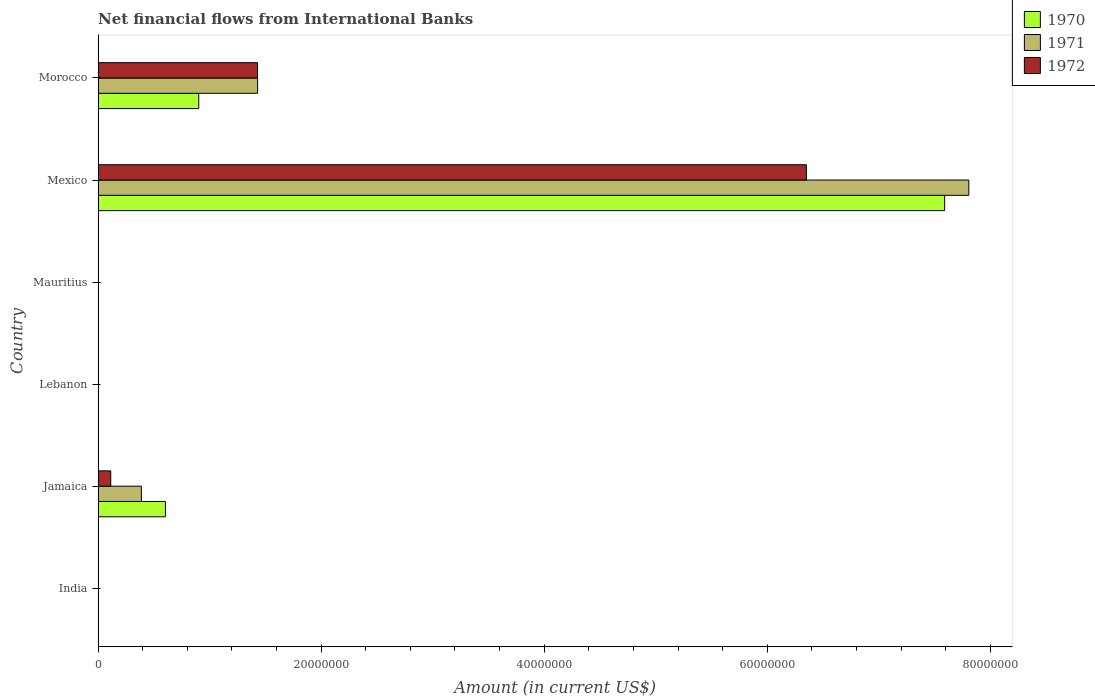How many bars are there on the 6th tick from the top?
Keep it short and to the point. 0. What is the label of the 1st group of bars from the top?
Give a very brief answer. Morocco. In how many cases, is the number of bars for a given country not equal to the number of legend labels?
Give a very brief answer. 3. What is the net financial aid flows in 1971 in Morocco?
Offer a very short reply. 1.43e+07. Across all countries, what is the maximum net financial aid flows in 1971?
Provide a short and direct response. 7.81e+07. In which country was the net financial aid flows in 1972 maximum?
Your answer should be compact. Mexico. What is the total net financial aid flows in 1971 in the graph?
Give a very brief answer. 9.63e+07. What is the difference between the net financial aid flows in 1972 in Morocco and the net financial aid flows in 1971 in Jamaica?
Ensure brevity in your answer.  1.04e+07. What is the average net financial aid flows in 1971 per country?
Give a very brief answer. 1.60e+07. What is the difference between the net financial aid flows in 1970 and net financial aid flows in 1971 in Mexico?
Your answer should be compact. -2.17e+06. What is the ratio of the net financial aid flows in 1971 in Jamaica to that in Morocco?
Your response must be concise. 0.27. What is the difference between the highest and the second highest net financial aid flows in 1970?
Give a very brief answer. 6.69e+07. What is the difference between the highest and the lowest net financial aid flows in 1971?
Make the answer very short. 7.81e+07. In how many countries, is the net financial aid flows in 1972 greater than the average net financial aid flows in 1972 taken over all countries?
Offer a very short reply. 2. Is it the case that in every country, the sum of the net financial aid flows in 1972 and net financial aid flows in 1971 is greater than the net financial aid flows in 1970?
Ensure brevity in your answer.  No. How many bars are there?
Your answer should be very brief. 9. How many countries are there in the graph?
Give a very brief answer. 6. Does the graph contain grids?
Give a very brief answer. No. How many legend labels are there?
Make the answer very short. 3. How are the legend labels stacked?
Make the answer very short. Vertical. What is the title of the graph?
Give a very brief answer. Net financial flows from International Banks. What is the label or title of the X-axis?
Offer a terse response. Amount (in current US$). What is the label or title of the Y-axis?
Your answer should be very brief. Country. What is the Amount (in current US$) of 1971 in India?
Your answer should be very brief. 0. What is the Amount (in current US$) of 1972 in India?
Keep it short and to the point. 0. What is the Amount (in current US$) of 1970 in Jamaica?
Keep it short and to the point. 6.04e+06. What is the Amount (in current US$) of 1971 in Jamaica?
Offer a very short reply. 3.88e+06. What is the Amount (in current US$) of 1972 in Jamaica?
Provide a succinct answer. 1.14e+06. What is the Amount (in current US$) in 1970 in Lebanon?
Make the answer very short. 0. What is the Amount (in current US$) of 1971 in Lebanon?
Give a very brief answer. 0. What is the Amount (in current US$) in 1971 in Mauritius?
Offer a very short reply. 0. What is the Amount (in current US$) in 1970 in Mexico?
Provide a short and direct response. 7.59e+07. What is the Amount (in current US$) of 1971 in Mexico?
Offer a very short reply. 7.81e+07. What is the Amount (in current US$) of 1972 in Mexico?
Your response must be concise. 6.35e+07. What is the Amount (in current US$) of 1970 in Morocco?
Provide a short and direct response. 9.03e+06. What is the Amount (in current US$) in 1971 in Morocco?
Your answer should be very brief. 1.43e+07. What is the Amount (in current US$) in 1972 in Morocco?
Your answer should be compact. 1.43e+07. Across all countries, what is the maximum Amount (in current US$) of 1970?
Offer a terse response. 7.59e+07. Across all countries, what is the maximum Amount (in current US$) in 1971?
Your answer should be very brief. 7.81e+07. Across all countries, what is the maximum Amount (in current US$) of 1972?
Offer a very short reply. 6.35e+07. Across all countries, what is the minimum Amount (in current US$) of 1972?
Offer a terse response. 0. What is the total Amount (in current US$) in 1970 in the graph?
Make the answer very short. 9.10e+07. What is the total Amount (in current US$) of 1971 in the graph?
Your answer should be very brief. 9.63e+07. What is the total Amount (in current US$) in 1972 in the graph?
Make the answer very short. 7.89e+07. What is the difference between the Amount (in current US$) in 1970 in Jamaica and that in Mexico?
Keep it short and to the point. -6.99e+07. What is the difference between the Amount (in current US$) in 1971 in Jamaica and that in Mexico?
Ensure brevity in your answer.  -7.42e+07. What is the difference between the Amount (in current US$) in 1972 in Jamaica and that in Mexico?
Your response must be concise. -6.24e+07. What is the difference between the Amount (in current US$) of 1970 in Jamaica and that in Morocco?
Provide a succinct answer. -2.99e+06. What is the difference between the Amount (in current US$) of 1971 in Jamaica and that in Morocco?
Offer a very short reply. -1.04e+07. What is the difference between the Amount (in current US$) of 1972 in Jamaica and that in Morocco?
Provide a succinct answer. -1.32e+07. What is the difference between the Amount (in current US$) in 1970 in Mexico and that in Morocco?
Provide a succinct answer. 6.69e+07. What is the difference between the Amount (in current US$) in 1971 in Mexico and that in Morocco?
Make the answer very short. 6.38e+07. What is the difference between the Amount (in current US$) of 1972 in Mexico and that in Morocco?
Make the answer very short. 4.92e+07. What is the difference between the Amount (in current US$) in 1970 in Jamaica and the Amount (in current US$) in 1971 in Mexico?
Give a very brief answer. -7.20e+07. What is the difference between the Amount (in current US$) in 1970 in Jamaica and the Amount (in current US$) in 1972 in Mexico?
Keep it short and to the point. -5.75e+07. What is the difference between the Amount (in current US$) of 1971 in Jamaica and the Amount (in current US$) of 1972 in Mexico?
Make the answer very short. -5.96e+07. What is the difference between the Amount (in current US$) in 1970 in Jamaica and the Amount (in current US$) in 1971 in Morocco?
Provide a short and direct response. -8.26e+06. What is the difference between the Amount (in current US$) of 1970 in Jamaica and the Amount (in current US$) of 1972 in Morocco?
Keep it short and to the point. -8.25e+06. What is the difference between the Amount (in current US$) of 1971 in Jamaica and the Amount (in current US$) of 1972 in Morocco?
Keep it short and to the point. -1.04e+07. What is the difference between the Amount (in current US$) in 1970 in Mexico and the Amount (in current US$) in 1971 in Morocco?
Ensure brevity in your answer.  6.16e+07. What is the difference between the Amount (in current US$) in 1970 in Mexico and the Amount (in current US$) in 1972 in Morocco?
Ensure brevity in your answer.  6.16e+07. What is the difference between the Amount (in current US$) of 1971 in Mexico and the Amount (in current US$) of 1972 in Morocco?
Your answer should be compact. 6.38e+07. What is the average Amount (in current US$) in 1970 per country?
Your answer should be compact. 1.52e+07. What is the average Amount (in current US$) of 1971 per country?
Give a very brief answer. 1.60e+07. What is the average Amount (in current US$) in 1972 per country?
Offer a very short reply. 1.32e+07. What is the difference between the Amount (in current US$) of 1970 and Amount (in current US$) of 1971 in Jamaica?
Keep it short and to the point. 2.16e+06. What is the difference between the Amount (in current US$) of 1970 and Amount (in current US$) of 1972 in Jamaica?
Offer a terse response. 4.90e+06. What is the difference between the Amount (in current US$) in 1971 and Amount (in current US$) in 1972 in Jamaica?
Offer a very short reply. 2.74e+06. What is the difference between the Amount (in current US$) of 1970 and Amount (in current US$) of 1971 in Mexico?
Your answer should be compact. -2.17e+06. What is the difference between the Amount (in current US$) of 1970 and Amount (in current US$) of 1972 in Mexico?
Keep it short and to the point. 1.24e+07. What is the difference between the Amount (in current US$) of 1971 and Amount (in current US$) of 1972 in Mexico?
Give a very brief answer. 1.46e+07. What is the difference between the Amount (in current US$) of 1970 and Amount (in current US$) of 1971 in Morocco?
Provide a short and direct response. -5.28e+06. What is the difference between the Amount (in current US$) of 1970 and Amount (in current US$) of 1972 in Morocco?
Your answer should be very brief. -5.27e+06. What is the ratio of the Amount (in current US$) in 1970 in Jamaica to that in Mexico?
Provide a short and direct response. 0.08. What is the ratio of the Amount (in current US$) of 1971 in Jamaica to that in Mexico?
Your answer should be compact. 0.05. What is the ratio of the Amount (in current US$) of 1972 in Jamaica to that in Mexico?
Offer a very short reply. 0.02. What is the ratio of the Amount (in current US$) of 1970 in Jamaica to that in Morocco?
Provide a succinct answer. 0.67. What is the ratio of the Amount (in current US$) in 1971 in Jamaica to that in Morocco?
Your answer should be very brief. 0.27. What is the ratio of the Amount (in current US$) of 1972 in Jamaica to that in Morocco?
Give a very brief answer. 0.08. What is the ratio of the Amount (in current US$) in 1970 in Mexico to that in Morocco?
Offer a very short reply. 8.41. What is the ratio of the Amount (in current US$) of 1971 in Mexico to that in Morocco?
Offer a terse response. 5.46. What is the ratio of the Amount (in current US$) in 1972 in Mexico to that in Morocco?
Ensure brevity in your answer.  4.44. What is the difference between the highest and the second highest Amount (in current US$) of 1970?
Ensure brevity in your answer.  6.69e+07. What is the difference between the highest and the second highest Amount (in current US$) of 1971?
Give a very brief answer. 6.38e+07. What is the difference between the highest and the second highest Amount (in current US$) of 1972?
Your response must be concise. 4.92e+07. What is the difference between the highest and the lowest Amount (in current US$) in 1970?
Keep it short and to the point. 7.59e+07. What is the difference between the highest and the lowest Amount (in current US$) in 1971?
Ensure brevity in your answer.  7.81e+07. What is the difference between the highest and the lowest Amount (in current US$) in 1972?
Offer a terse response. 6.35e+07. 